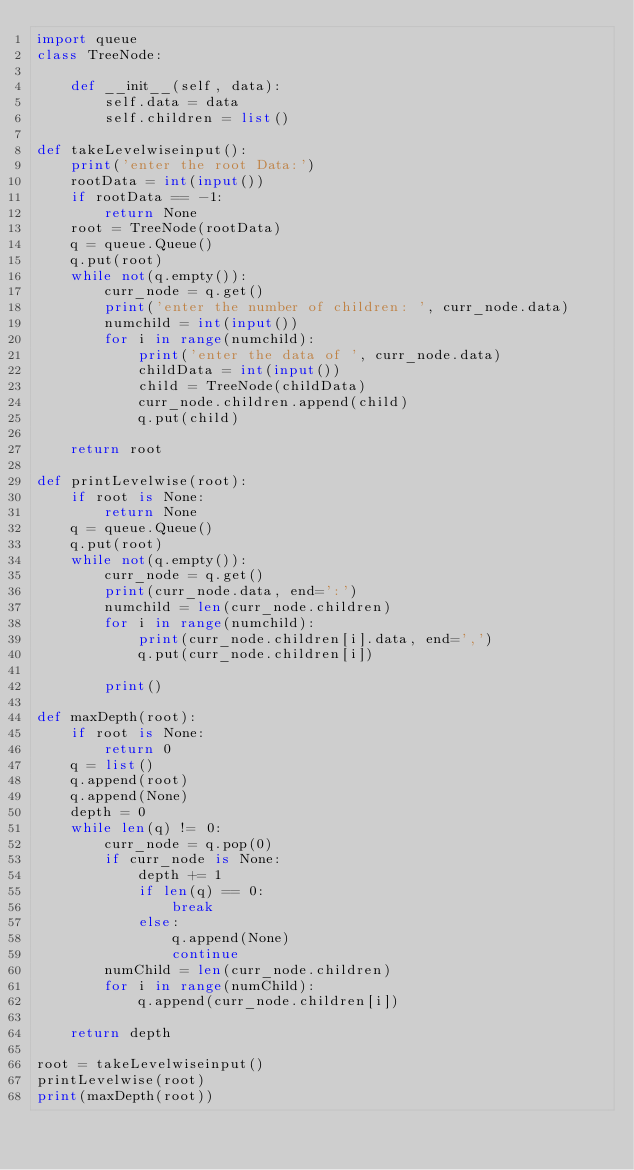Convert code to text. <code><loc_0><loc_0><loc_500><loc_500><_Python_>import queue
class TreeNode:

    def __init__(self, data):
        self.data = data
        self.children = list()

def takeLevelwiseinput():
    print('enter the root Data:')
    rootData = int(input())
    if rootData == -1:
        return None
    root = TreeNode(rootData)
    q = queue.Queue()
    q.put(root)
    while not(q.empty()):
        curr_node = q.get()
        print('enter the number of children: ', curr_node.data)
        numchild = int(input())
        for i in range(numchild):
            print('enter the data of ', curr_node.data)
            childData = int(input())
            child = TreeNode(childData)
            curr_node.children.append(child)
            q.put(child)
        
    return root

def printLevelwise(root):
    if root is None:
        return None
    q = queue.Queue()
    q.put(root)
    while not(q.empty()):
        curr_node = q.get()
        print(curr_node.data, end=':')
        numchild = len(curr_node.children)
        for i in range(numchild):
            print(curr_node.children[i].data, end=',')
            q.put(curr_node.children[i])

        print()

def maxDepth(root):
    if root is None:
        return 0
    q = list()
    q.append(root)
    q.append(None)
    depth = 0
    while len(q) != 0:
        curr_node = q.pop(0)
        if curr_node is None:
            depth += 1
            if len(q) == 0:
                break
            else:
                q.append(None)
                continue
        numChild = len(curr_node.children)
        for i in range(numChild):
            q.append(curr_node.children[i])
        
    return depth

root = takeLevelwiseinput()
printLevelwise(root)
print(maxDepth(root))</code> 